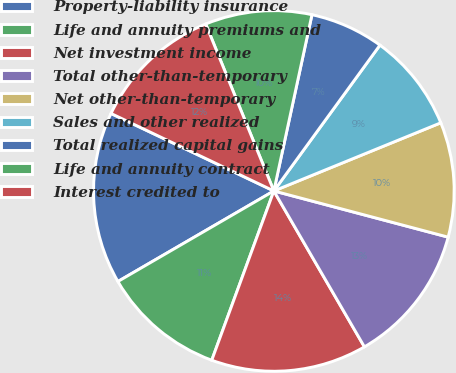<chart> <loc_0><loc_0><loc_500><loc_500><pie_chart><fcel>Property-liability insurance<fcel>Life and annuity premiums and<fcel>Net investment income<fcel>Total other-than-temporary<fcel>Net other-than-temporary<fcel>Sales and other realized<fcel>Total realized capital gains<fcel>Life and annuity contract<fcel>Interest credited to<nl><fcel>15.44%<fcel>11.03%<fcel>13.97%<fcel>12.5%<fcel>10.29%<fcel>8.82%<fcel>6.62%<fcel>9.56%<fcel>11.76%<nl></chart> 